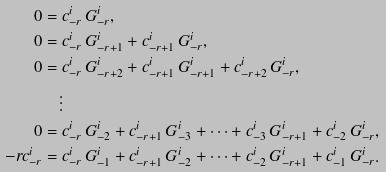Convert formula to latex. <formula><loc_0><loc_0><loc_500><loc_500>0 & = c _ { - r } ^ { i } \, G _ { - r } ^ { i } , \\ 0 & = c _ { - r } ^ { i } \, G _ { - r + 1 } ^ { i } + c _ { - r + 1 } ^ { i } \, G _ { - r } ^ { i } , \\ 0 & = c _ { - r } ^ { i } \, G _ { - r + 2 } ^ { i } + c _ { - r + 1 } ^ { i } \, G _ { - r + 1 } ^ { i } + c _ { - r + 2 } ^ { i } \, G _ { - r } ^ { i } , \\ & \quad \vdots \\ 0 & = c _ { - r } ^ { i } \, G _ { - 2 } ^ { i } + c _ { - r + 1 } ^ { i } \, G _ { - 3 } ^ { i } + \cdots + c _ { - 3 } ^ { i } \, G _ { - r + 1 } ^ { i } + c _ { - 2 } ^ { i } \, G _ { - r } ^ { i } , \\ - r c _ { - r } ^ { i } & = c _ { - r } ^ { i } \, G _ { - 1 } ^ { i } + c _ { - r + 1 } ^ { i } \, G _ { - 2 } ^ { i } + \cdots + c _ { - 2 } ^ { i } \, G _ { - r + 1 } ^ { i } + c _ { - 1 } ^ { i } \, G _ { - r } ^ { i } .</formula> 